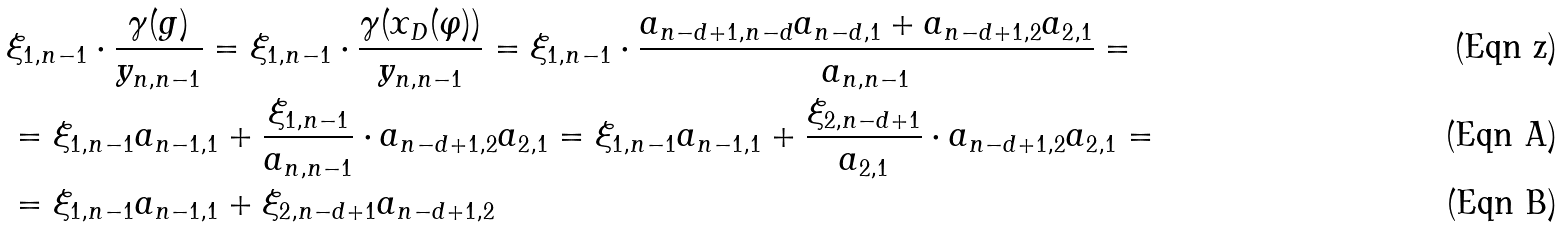Convert formula to latex. <formula><loc_0><loc_0><loc_500><loc_500>& \xi _ { 1 , n - 1 } \cdot \frac { \gamma ( g ) } { y _ { n , n - 1 } } = \xi _ { 1 , n - 1 } \cdot \frac { \gamma ( x _ { D } ( \varphi ) ) } { y _ { n , n - 1 } } = \xi _ { 1 , n - 1 } \cdot \frac { a _ { n - d + 1 , n - d } a _ { n - d , 1 } + a _ { n - d + 1 , 2 } a _ { 2 , 1 } } { a _ { n , n - 1 } } = \\ & = \xi _ { 1 , n - 1 } a _ { n - 1 , 1 } + \frac { \xi _ { 1 , n - 1 } } { a _ { n , n - 1 } } \cdot a _ { n - d + 1 , 2 } a _ { 2 , 1 } = \xi _ { 1 , n - 1 } a _ { n - 1 , 1 } + \frac { \xi _ { 2 , n - d + 1 } } { a _ { 2 , 1 } } \cdot a _ { n - d + 1 , 2 } a _ { 2 , 1 } = \\ & = \xi _ { 1 , n - 1 } a _ { n - 1 , 1 } + \xi _ { 2 , n - d + 1 } a _ { n - d + 1 , 2 }</formula> 